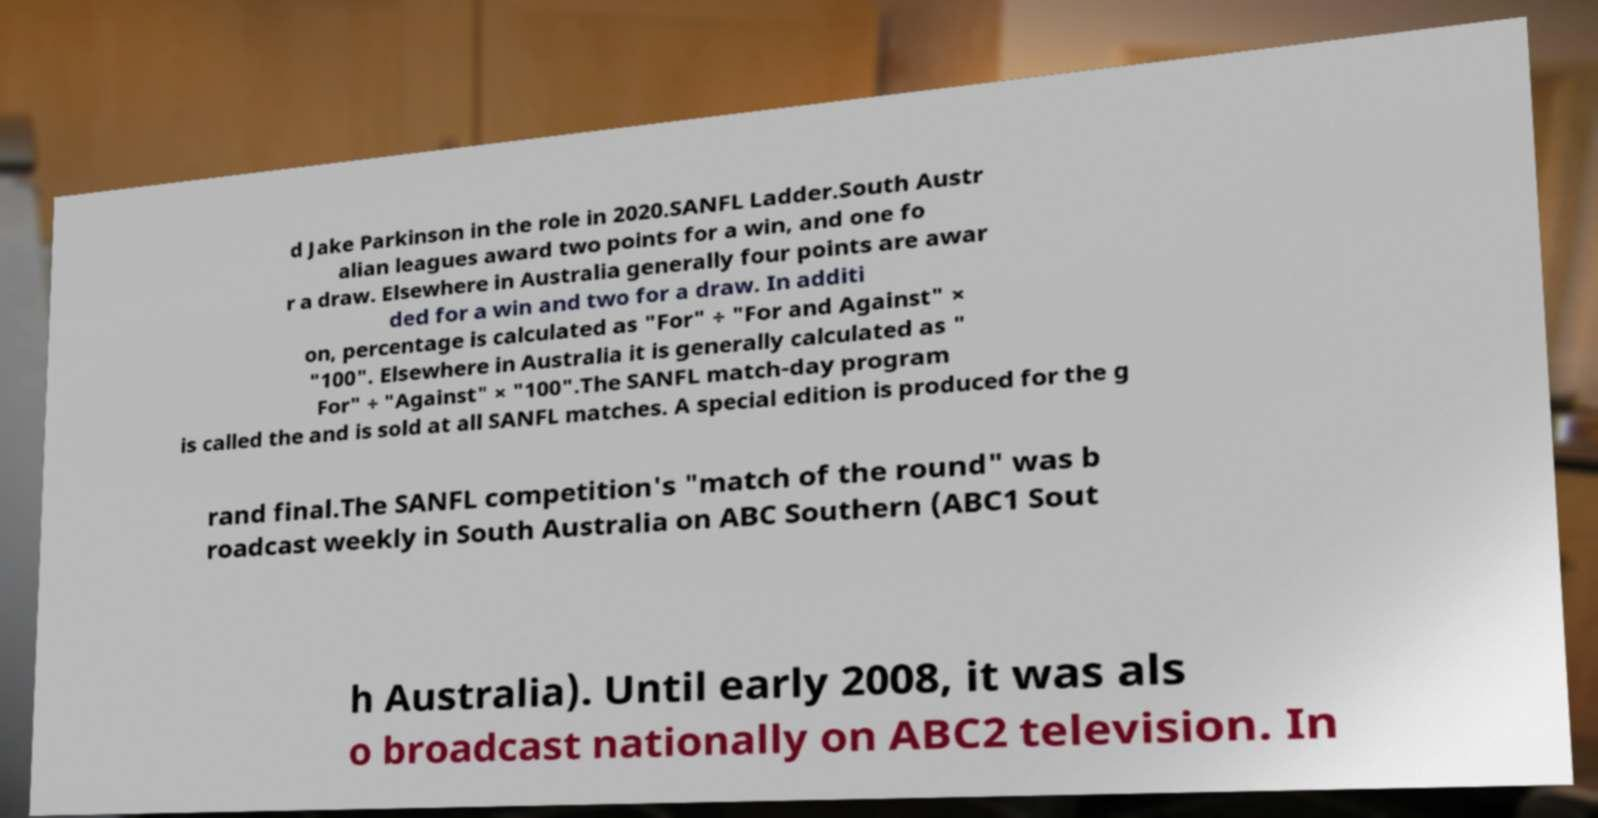For documentation purposes, I need the text within this image transcribed. Could you provide that? d Jake Parkinson in the role in 2020.SANFL Ladder.South Austr alian leagues award two points for a win, and one fo r a draw. Elsewhere in Australia generally four points are awar ded for a win and two for a draw. In additi on, percentage is calculated as "For" ÷ "For and Against" × "100". Elsewhere in Australia it is generally calculated as " For" ÷ "Against" × "100".The SANFL match-day program is called the and is sold at all SANFL matches. A special edition is produced for the g rand final.The SANFL competition's "match of the round" was b roadcast weekly in South Australia on ABC Southern (ABC1 Sout h Australia). Until early 2008, it was als o broadcast nationally on ABC2 television. In 